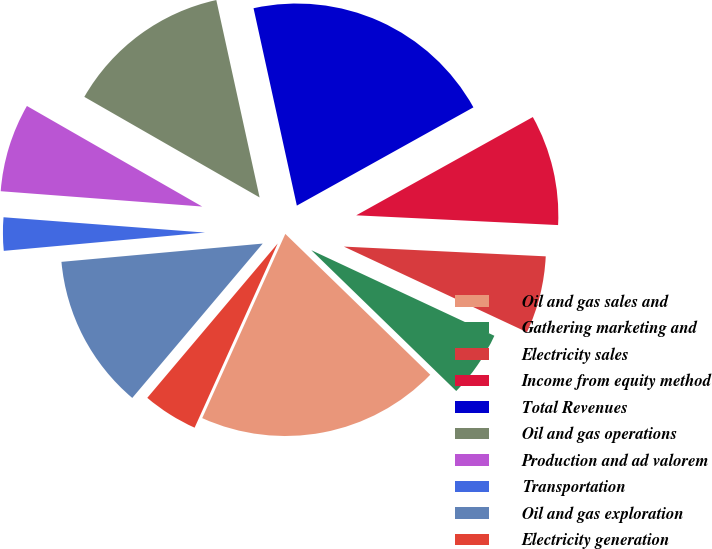<chart> <loc_0><loc_0><loc_500><loc_500><pie_chart><fcel>Oil and gas sales and<fcel>Gathering marketing and<fcel>Electricity sales<fcel>Income from equity method<fcel>Total Revenues<fcel>Oil and gas operations<fcel>Production and ad valorem<fcel>Transportation<fcel>Oil and gas exploration<fcel>Electricity generation<nl><fcel>19.47%<fcel>5.31%<fcel>6.19%<fcel>8.85%<fcel>20.35%<fcel>13.27%<fcel>7.08%<fcel>2.65%<fcel>12.39%<fcel>4.42%<nl></chart> 